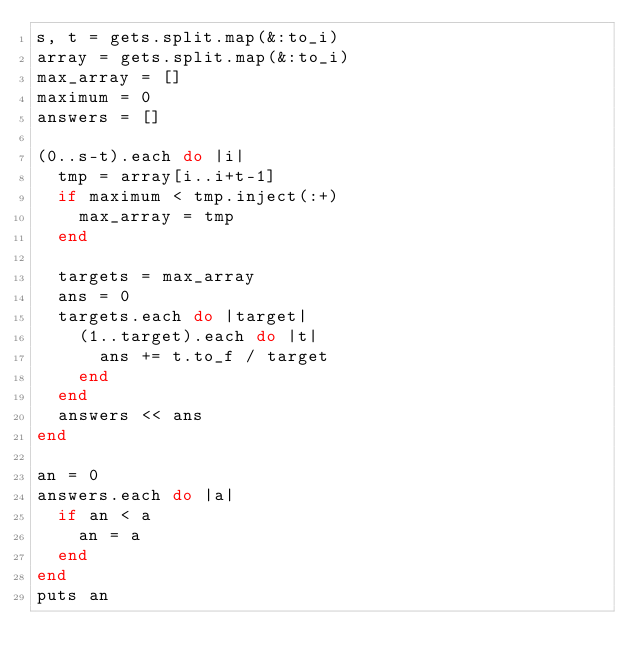<code> <loc_0><loc_0><loc_500><loc_500><_Ruby_>s, t = gets.split.map(&:to_i)
array = gets.split.map(&:to_i)
max_array = []
maximum = 0
answers = []

(0..s-t).each do |i|
  tmp = array[i..i+t-1]
  if maximum < tmp.inject(:+)
    max_array = tmp
  end

  targets = max_array
  ans = 0
  targets.each do |target|
    (1..target).each do |t|
      ans += t.to_f / target
    end
  end
  answers << ans
end

an = 0
answers.each do |a|
  if an < a
    an = a
  end
end
puts an
</code> 